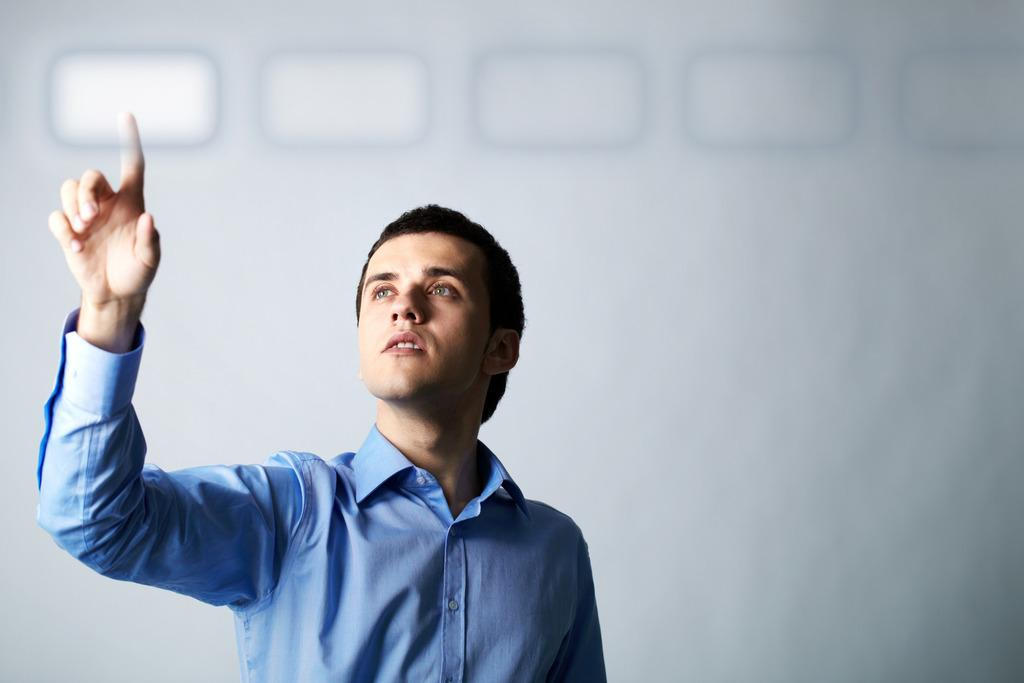What is the main subject of the image? There is a person standing in the image. What is the person wearing? The person is wearing a blue dress. What color is the background of the image? The background of the image is white. How many cakes are on the person's head in the image? There are no cakes present in the image; the person is wearing a blue dress and standing in front of a white background. 